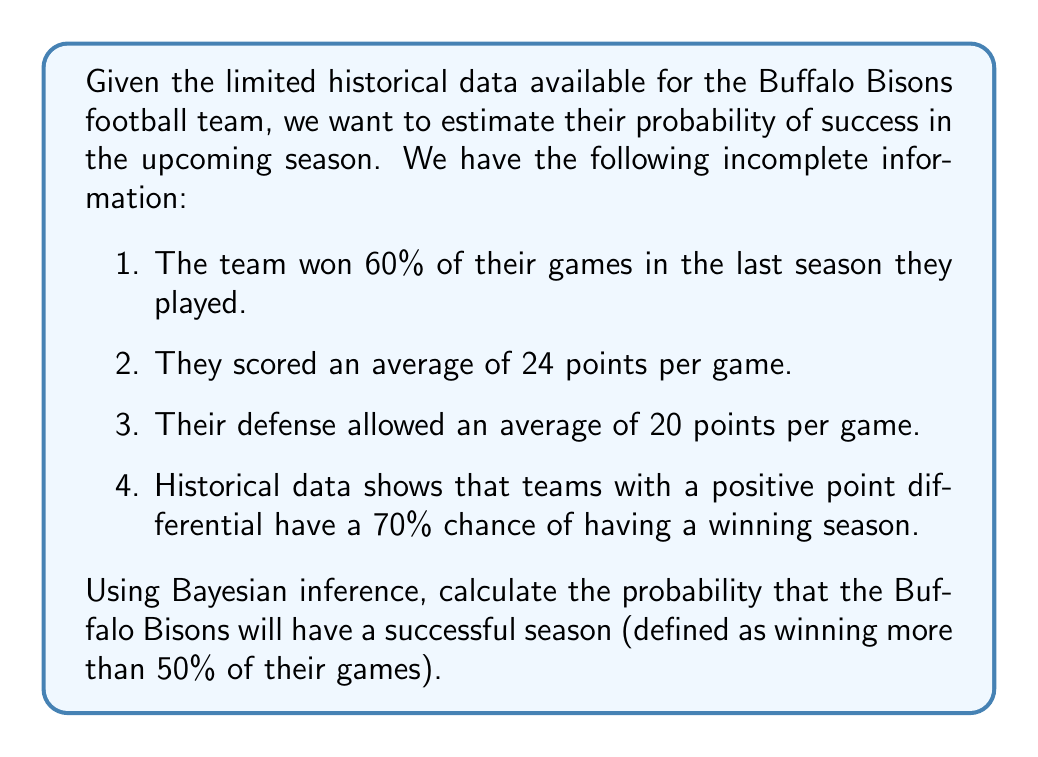What is the answer to this math problem? To solve this inverse problem using Bayesian inference, we'll follow these steps:

1. Define our prior probability based on last season's win percentage:
   $P(S) = 0.60$, where S represents a successful season.

2. Calculate the likelihood of the team's performance given a successful season:
   We'll use the point differential as our key statistic.
   Point differential = Average points scored - Average points allowed
   $24 - 20 = 4$ (positive)

   $P(D|S) = 0.70$, where D represents a positive point differential.

3. Calculate the total probability of a positive point differential:
   $P(D) = P(D|S) * P(S) + P(D|\text{not }S) * P(\text{not }S)$
   $P(D) = 0.70 * 0.60 + 0.30 * 0.40 = 0.54$

4. Apply Bayes' theorem to calculate the posterior probability:

   $$P(S|D) = \frac{P(D|S) * P(S)}{P(D)}$$

   $$P(S|D) = \frac{0.70 * 0.60}{0.54} \approx 0.7778$$

Therefore, based on the available data and Bayesian inference, the probability that the Buffalo Bisons will have a successful season is approximately 0.7778 or 77.78%.
Answer: $0.7778$ or $77.78\%$ 